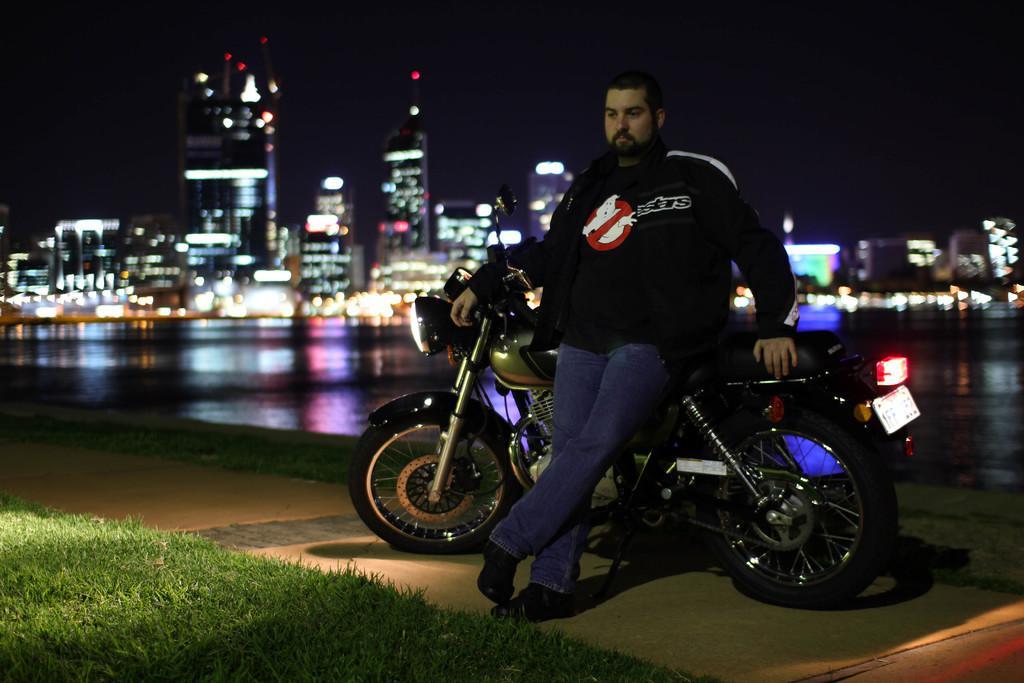Could you give a brief overview of what you see in this image? In this image, we can see a person and there is a bike. In the background, there are buildings and lights. At the bottom, there is water and ground. 